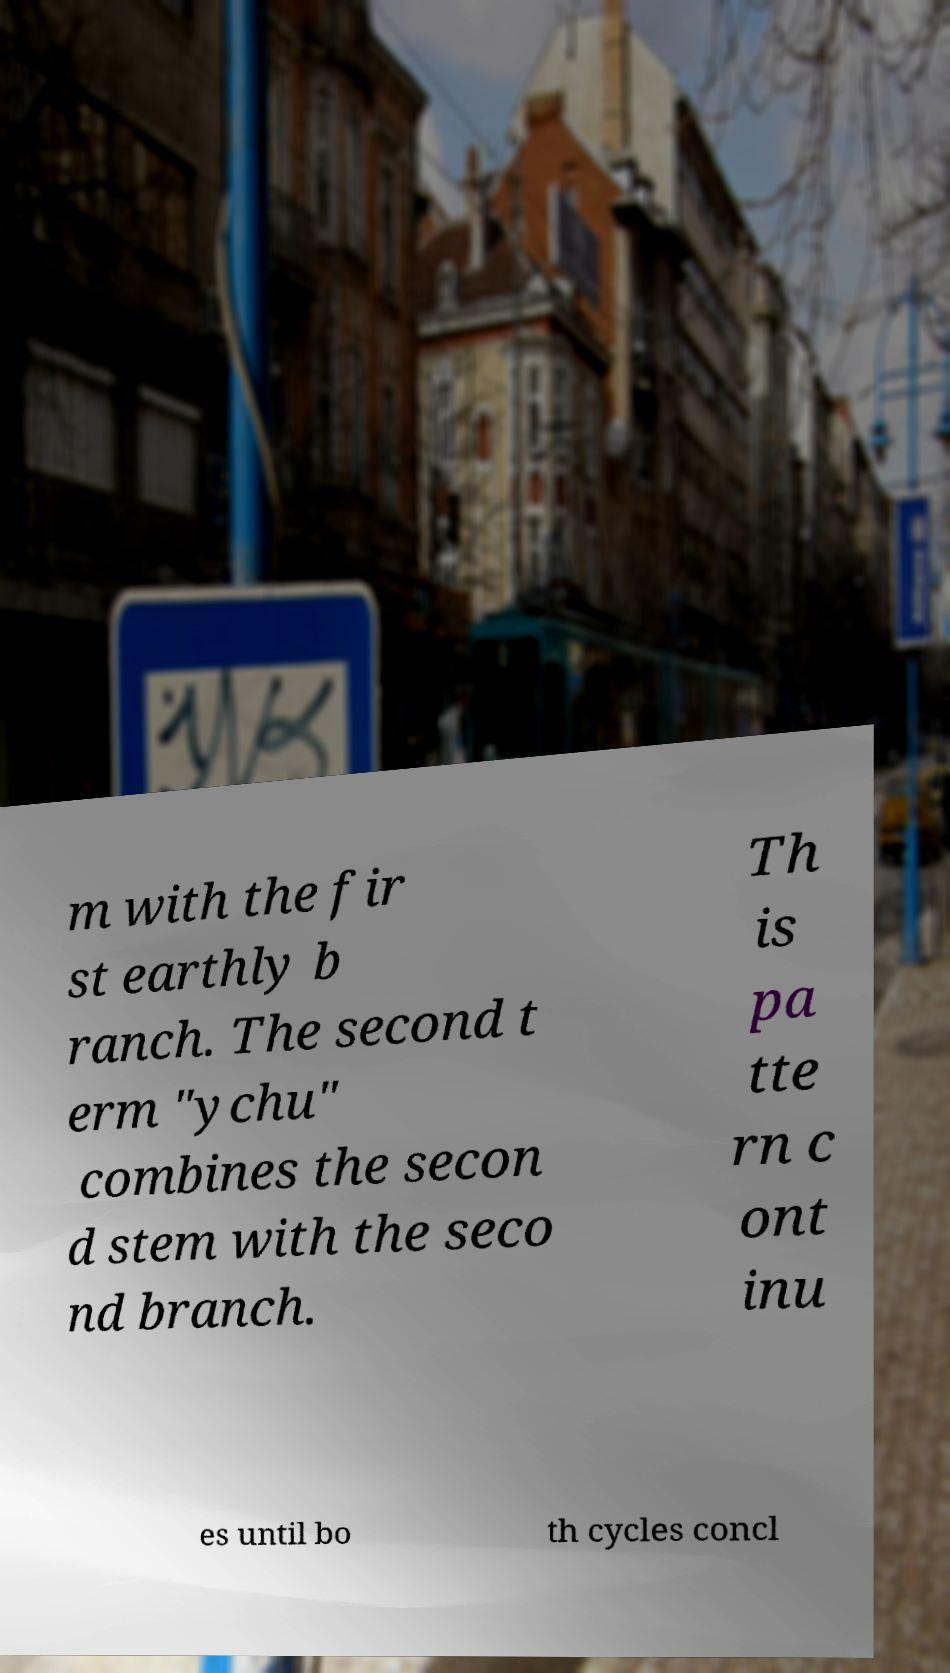Can you read and provide the text displayed in the image?This photo seems to have some interesting text. Can you extract and type it out for me? m with the fir st earthly b ranch. The second t erm "ychu" combines the secon d stem with the seco nd branch. Th is pa tte rn c ont inu es until bo th cycles concl 